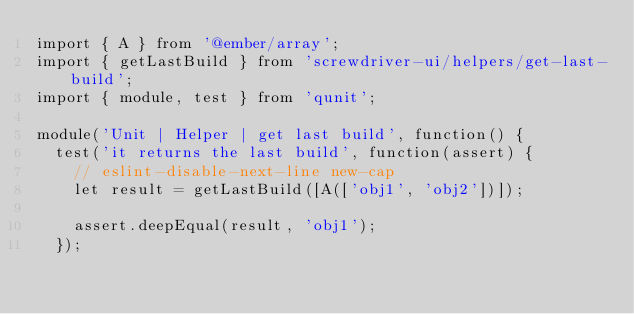Convert code to text. <code><loc_0><loc_0><loc_500><loc_500><_JavaScript_>import { A } from '@ember/array';
import { getLastBuild } from 'screwdriver-ui/helpers/get-last-build';
import { module, test } from 'qunit';

module('Unit | Helper | get last build', function() {
  test('it returns the last build', function(assert) {
    // eslint-disable-next-line new-cap
    let result = getLastBuild([A(['obj1', 'obj2'])]);

    assert.deepEqual(result, 'obj1');
  });
</code> 